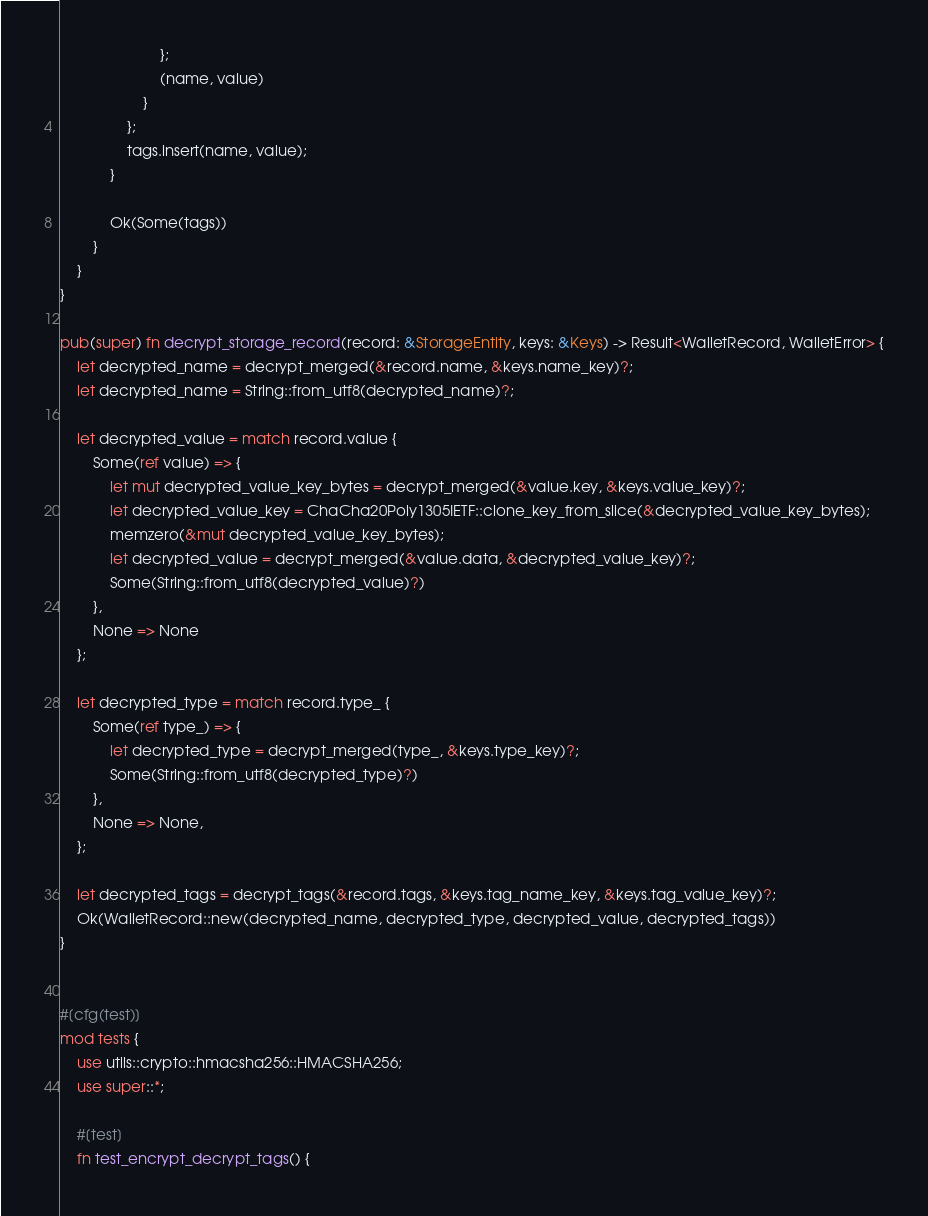<code> <loc_0><loc_0><loc_500><loc_500><_Rust_>                        };
                        (name, value)
                    }
                };
                tags.insert(name, value);
            }

            Ok(Some(tags))
        }
    }
}

pub(super) fn decrypt_storage_record(record: &StorageEntity, keys: &Keys) -> Result<WalletRecord, WalletError> {
    let decrypted_name = decrypt_merged(&record.name, &keys.name_key)?;
    let decrypted_name = String::from_utf8(decrypted_name)?;

    let decrypted_value = match record.value {
        Some(ref value) => {
            let mut decrypted_value_key_bytes = decrypt_merged(&value.key, &keys.value_key)?;
            let decrypted_value_key = ChaCha20Poly1305IETF::clone_key_from_slice(&decrypted_value_key_bytes);
            memzero(&mut decrypted_value_key_bytes);
            let decrypted_value = decrypt_merged(&value.data, &decrypted_value_key)?;
            Some(String::from_utf8(decrypted_value)?)
        },
        None => None
    };

    let decrypted_type = match record.type_ {
        Some(ref type_) => {
            let decrypted_type = decrypt_merged(type_, &keys.type_key)?;
            Some(String::from_utf8(decrypted_type)?)
        },
        None => None,
    };

    let decrypted_tags = decrypt_tags(&record.tags, &keys.tag_name_key, &keys.tag_value_key)?;
    Ok(WalletRecord::new(decrypted_name, decrypted_type, decrypted_value, decrypted_tags))
}


#[cfg(test)]
mod tests {
    use utils::crypto::hmacsha256::HMACSHA256;
    use super::*;

    #[test]
    fn test_encrypt_decrypt_tags() {</code> 